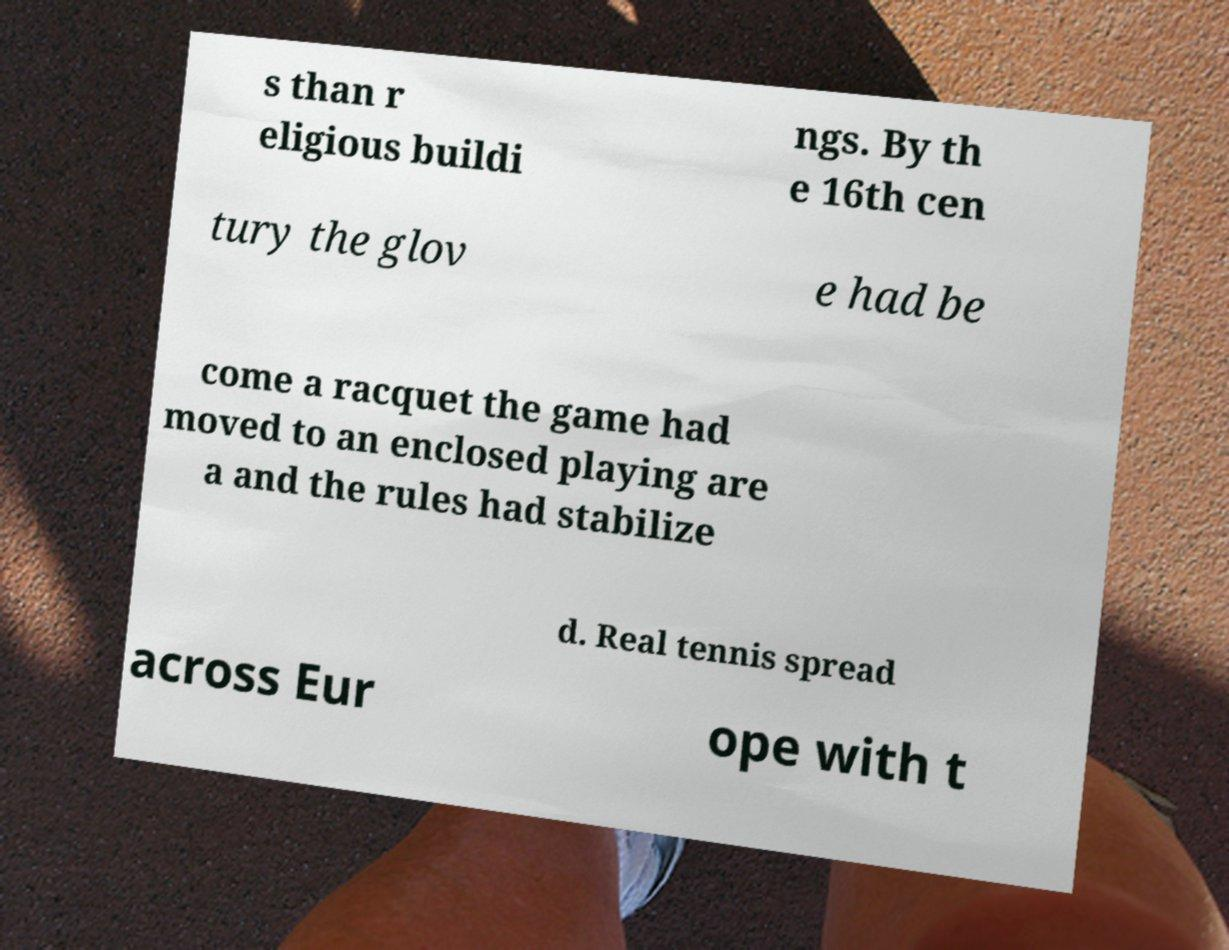There's text embedded in this image that I need extracted. Can you transcribe it verbatim? s than r eligious buildi ngs. By th e 16th cen tury the glov e had be come a racquet the game had moved to an enclosed playing are a and the rules had stabilize d. Real tennis spread across Eur ope with t 